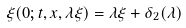<formula> <loc_0><loc_0><loc_500><loc_500>\xi ( 0 ; t , x , \lambda \xi ) = \lambda \xi + \delta _ { 2 } ( \lambda )</formula> 